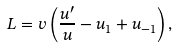Convert formula to latex. <formula><loc_0><loc_0><loc_500><loc_500>L = v \left ( \frac { u ^ { \prime } } { u } - u _ { 1 } + u _ { - 1 } \right ) ,</formula> 